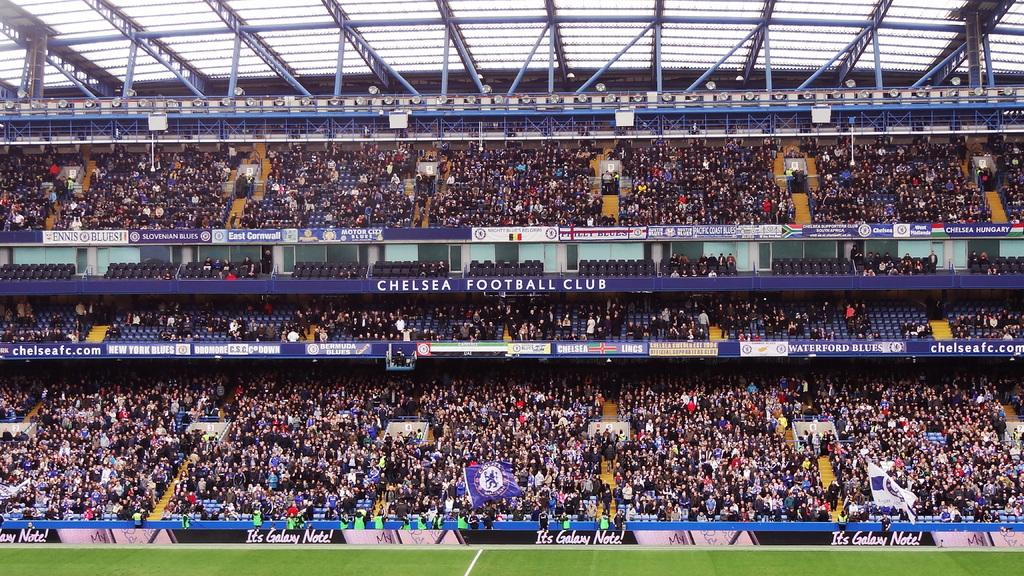<image>
Create a compact narrative representing the image presented. The stadium that Chelsea Football Club plays at is full. 